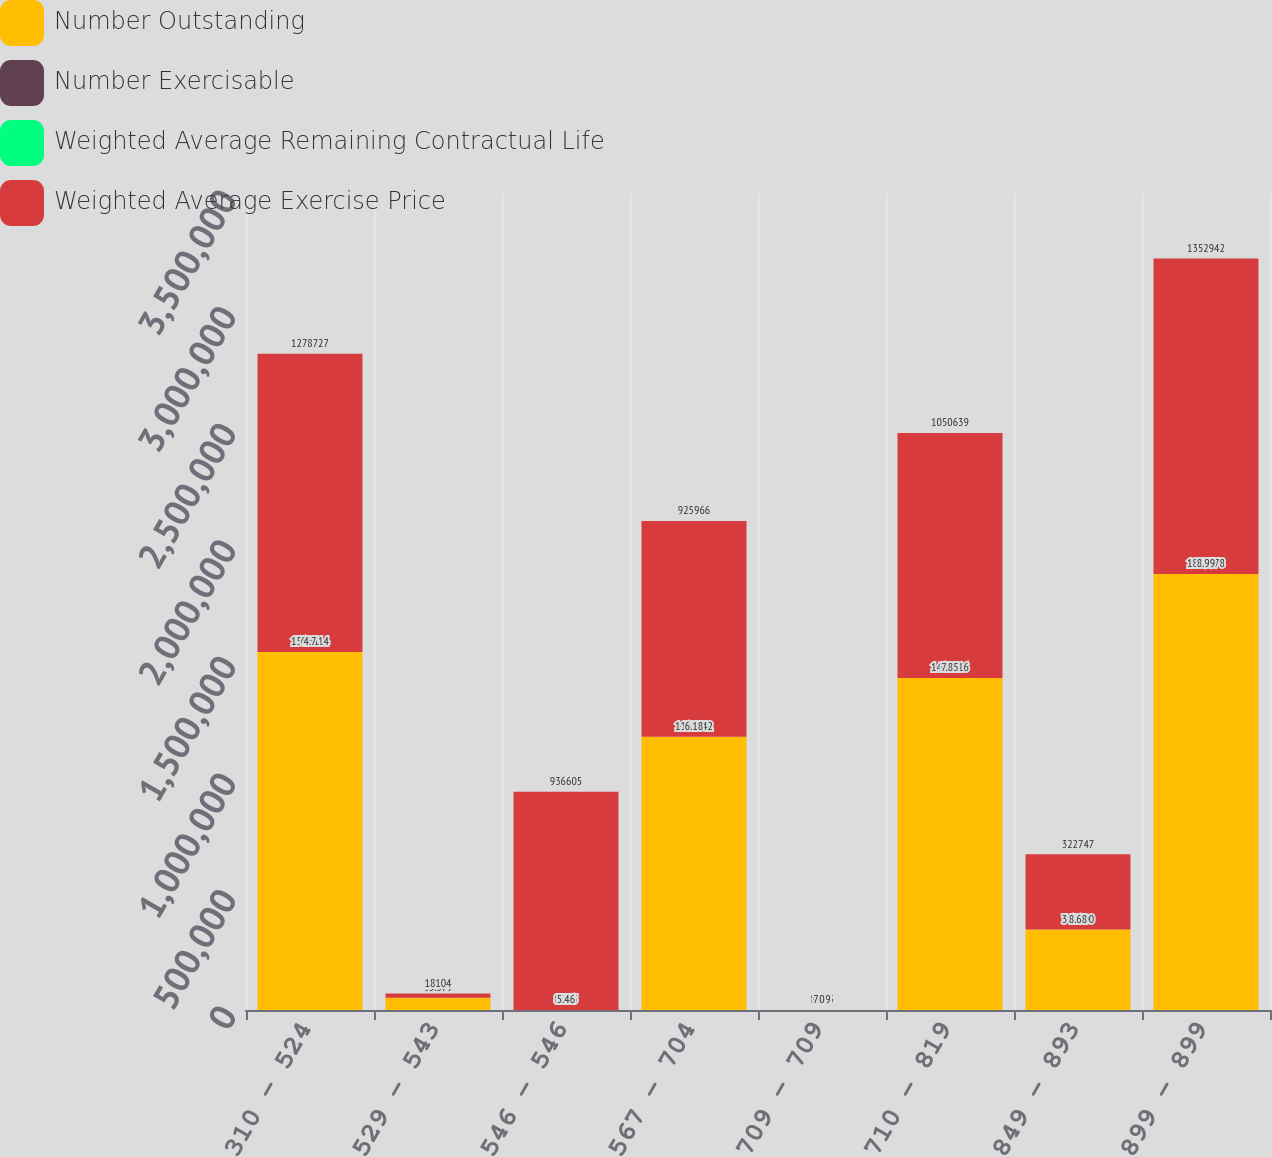Convert chart to OTSL. <chart><loc_0><loc_0><loc_500><loc_500><stacked_bar_chart><ecel><fcel>310 - 524<fcel>529 - 543<fcel>546 - 546<fcel>567 - 704<fcel>709 - 709<fcel>710 - 819<fcel>849 - 893<fcel>899 - 899<nl><fcel>Number Outstanding<fcel>1.53581e+06<fcel>53000<fcel>8.355<fcel>1.17154e+06<fcel>8.355<fcel>1.42432e+06<fcel>345000<fcel>1.87038e+06<nl><fcel>Number Exercisable<fcel>6.31<fcel>7.64<fcel>8.03<fcel>5.75<fcel>6.12<fcel>6.72<fcel>6.31<fcel>7.05<nl><fcel>Weighted Average Remaining Contractual Life<fcel>4.7<fcel>5.37<fcel>5.46<fcel>6.18<fcel>7.09<fcel>7.85<fcel>8.68<fcel>8.99<nl><fcel>Weighted Average Exercise Price<fcel>1.27873e+06<fcel>18104<fcel>936605<fcel>925966<fcel>0<fcel>1.05064e+06<fcel>322747<fcel>1.35294e+06<nl></chart> 